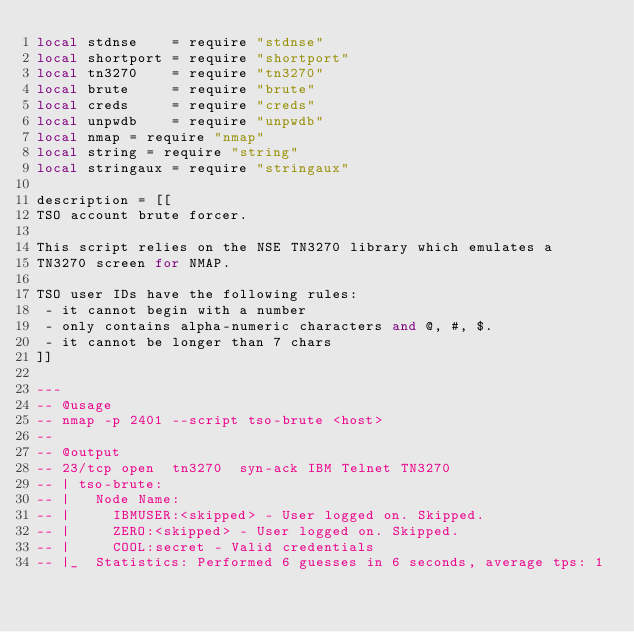<code> <loc_0><loc_0><loc_500><loc_500><_Lua_>local stdnse    = require "stdnse"
local shortport = require "shortport"
local tn3270    = require "tn3270"
local brute     = require "brute"
local creds     = require "creds"
local unpwdb    = require "unpwdb"
local nmap = require "nmap"
local string = require "string"
local stringaux = require "stringaux"

description = [[
TSO account brute forcer.

This script relies on the NSE TN3270 library which emulates a
TN3270 screen for NMAP.

TSO user IDs have the following rules:
 - it cannot begin with a number
 - only contains alpha-numeric characters and @, #, $.
 - it cannot be longer than 7 chars
]]

---
-- @usage
-- nmap -p 2401 --script tso-brute <host>
--
-- @output
-- 23/tcp open  tn3270  syn-ack IBM Telnet TN3270
-- | tso-brute:
-- |   Node Name:
-- |     IBMUSER:<skipped> - User logged on. Skipped.
-- |     ZERO:<skipped> - User logged on. Skipped.
-- |     COOL:secret - Valid credentials
-- |_  Statistics: Performed 6 guesses in 6 seconds, average tps: 1</code> 